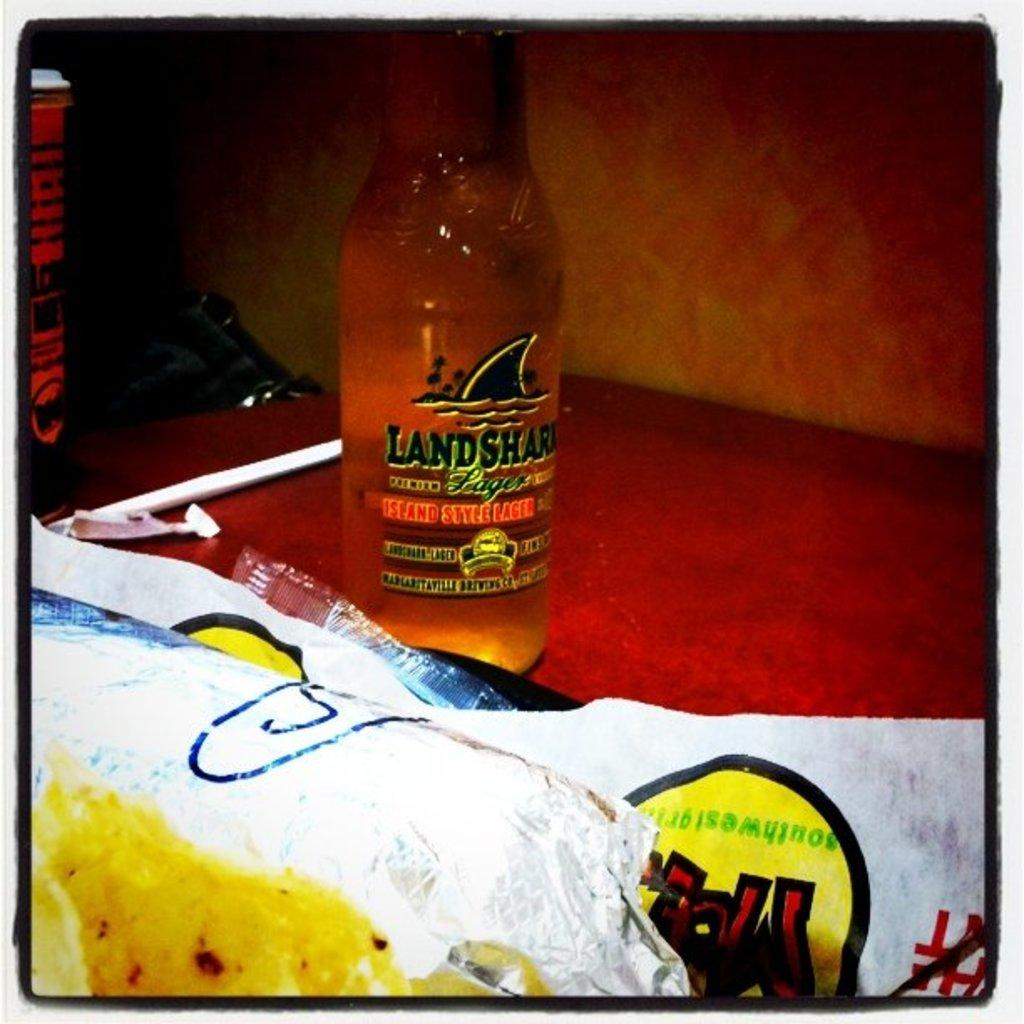What object can be seen in the image? There is a bottle in the image. Where is the bottle located? The bottle is on a table. How deep is the ocean in the image? There is no ocean present in the image; it only features a bottle on a table. 